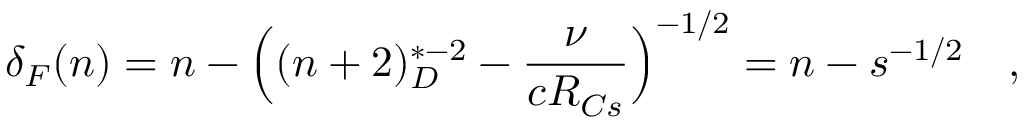Convert formula to latex. <formula><loc_0><loc_0><loc_500><loc_500>\delta _ { F } ( n ) = n - \left ( ( n + 2 ) _ { D } ^ { * - 2 } - \frac { \nu } { c R _ { C s } } \right ) ^ { - 1 / 2 } = n - s ^ { - 1 / 2 } \quad ,</formula> 